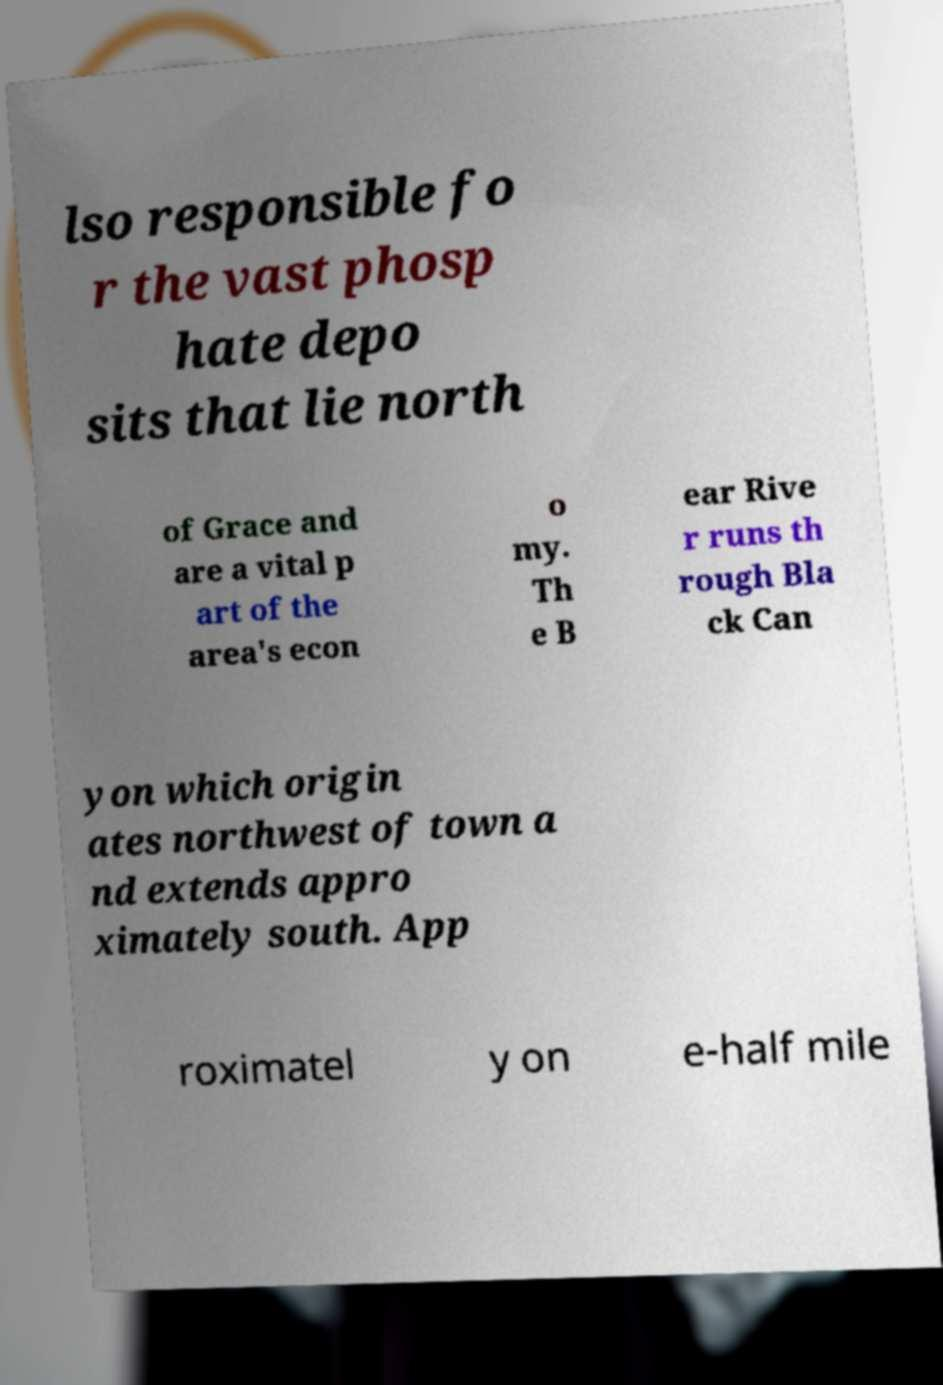Could you assist in decoding the text presented in this image and type it out clearly? lso responsible fo r the vast phosp hate depo sits that lie north of Grace and are a vital p art of the area's econ o my. Th e B ear Rive r runs th rough Bla ck Can yon which origin ates northwest of town a nd extends appro ximately south. App roximatel y on e-half mile 